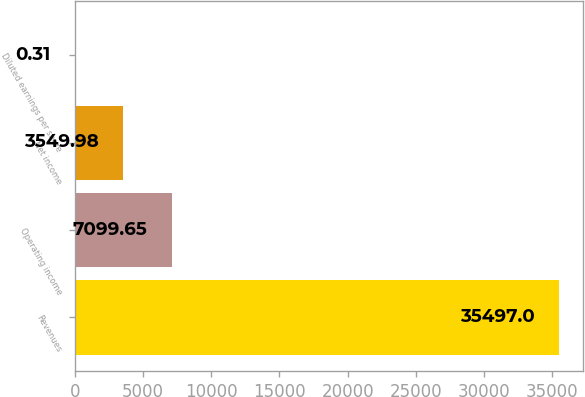Convert chart. <chart><loc_0><loc_0><loc_500><loc_500><bar_chart><fcel>Revenues<fcel>Operating income<fcel>Net income<fcel>Diluted earnings per share<nl><fcel>35497<fcel>7099.65<fcel>3549.98<fcel>0.31<nl></chart> 